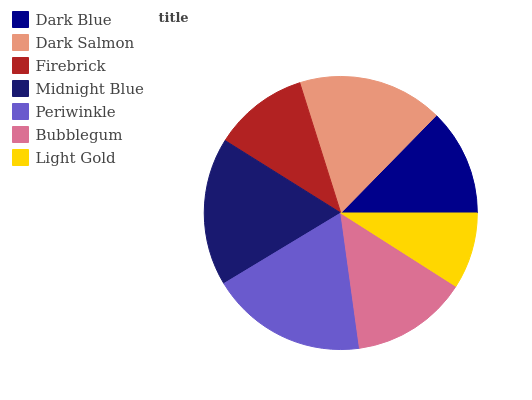Is Light Gold the minimum?
Answer yes or no. Yes. Is Periwinkle the maximum?
Answer yes or no. Yes. Is Dark Salmon the minimum?
Answer yes or no. No. Is Dark Salmon the maximum?
Answer yes or no. No. Is Dark Salmon greater than Dark Blue?
Answer yes or no. Yes. Is Dark Blue less than Dark Salmon?
Answer yes or no. Yes. Is Dark Blue greater than Dark Salmon?
Answer yes or no. No. Is Dark Salmon less than Dark Blue?
Answer yes or no. No. Is Bubblegum the high median?
Answer yes or no. Yes. Is Bubblegum the low median?
Answer yes or no. Yes. Is Midnight Blue the high median?
Answer yes or no. No. Is Periwinkle the low median?
Answer yes or no. No. 